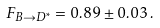<formula> <loc_0><loc_0><loc_500><loc_500>F _ { B \rightarrow D ^ { * } } = 0 . 8 9 \pm 0 . 0 3 \, .</formula> 